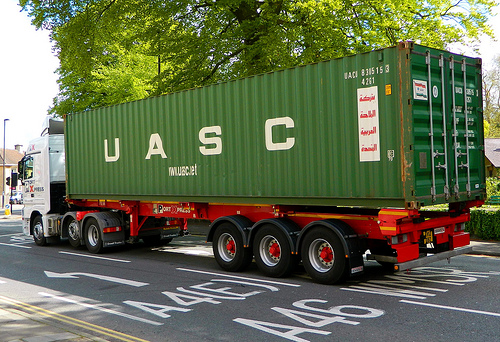What is the vehicle to the right of the lamp? The vehicle to the right of the lamp is a taxi. 